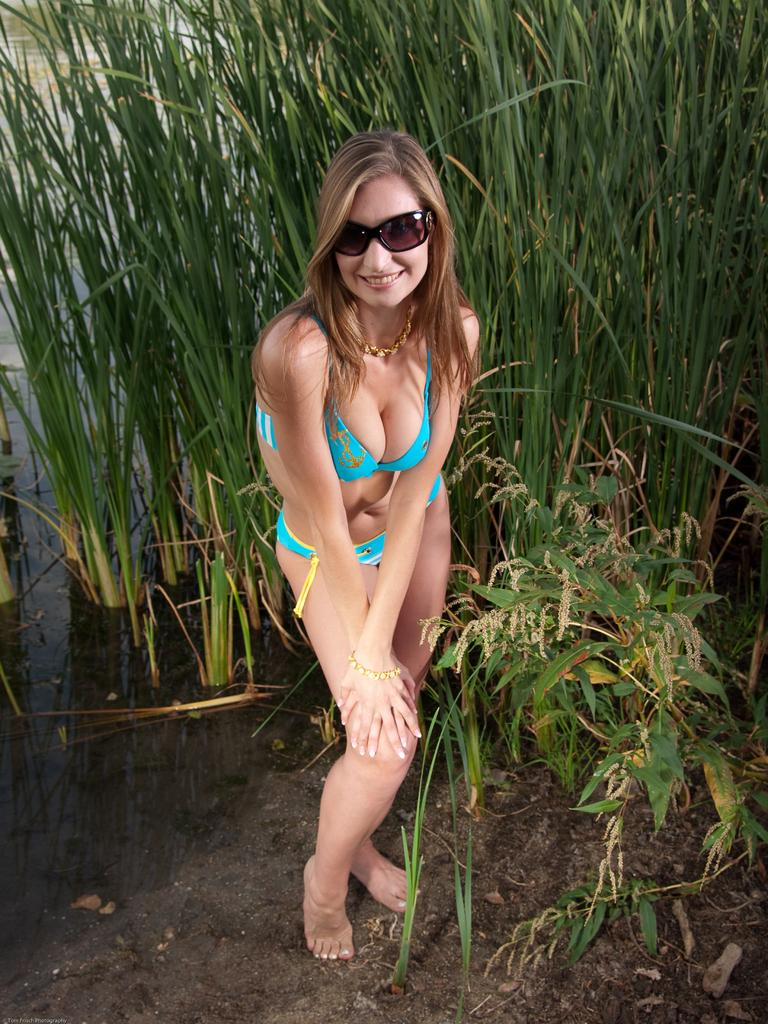Who is present in the image? There is a woman in the picture. What is the woman standing on? The woman is standing on a mud surface. What is the woman wearing? The woman is wearing a green bikini. What expression does the woman have? The woman is smiling. What type of vegetation can be seen in the background of the image? There are grass plants visible in the background of the image. How many eggs are visible in the image? There are no eggs visible in the image. What type of sea creature can be seen swimming in the background? There is no sea or sea creature present in the image. 